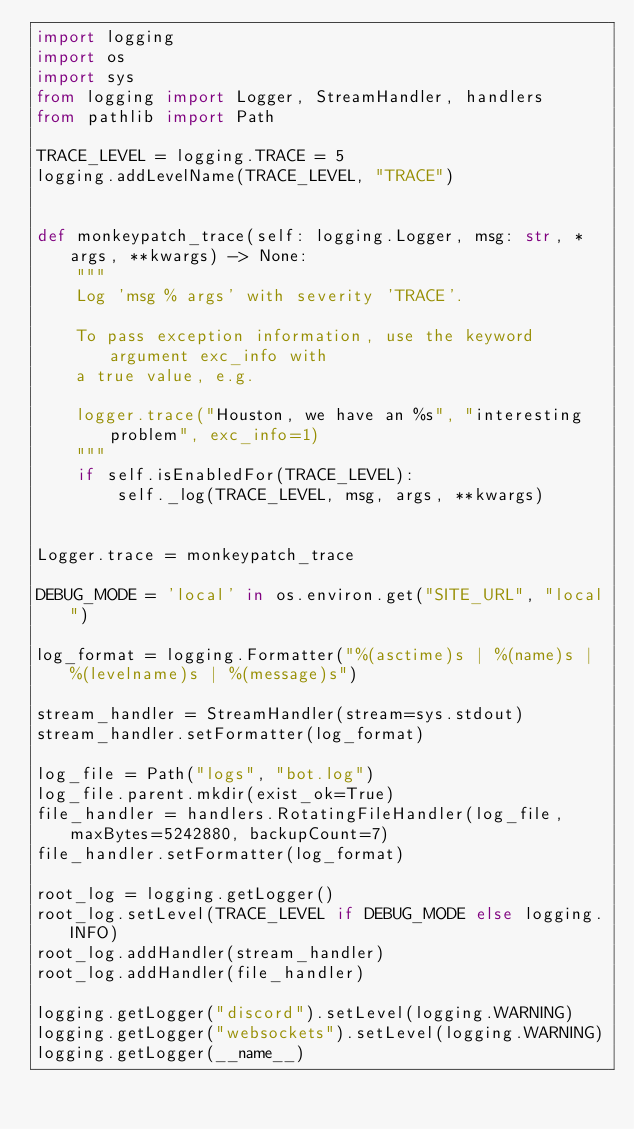<code> <loc_0><loc_0><loc_500><loc_500><_Python_>import logging
import os
import sys
from logging import Logger, StreamHandler, handlers
from pathlib import Path

TRACE_LEVEL = logging.TRACE = 5
logging.addLevelName(TRACE_LEVEL, "TRACE")


def monkeypatch_trace(self: logging.Logger, msg: str, *args, **kwargs) -> None:
    """
    Log 'msg % args' with severity 'TRACE'.

    To pass exception information, use the keyword argument exc_info with
    a true value, e.g.

    logger.trace("Houston, we have an %s", "interesting problem", exc_info=1)
    """
    if self.isEnabledFor(TRACE_LEVEL):
        self._log(TRACE_LEVEL, msg, args, **kwargs)


Logger.trace = monkeypatch_trace

DEBUG_MODE = 'local' in os.environ.get("SITE_URL", "local")

log_format = logging.Formatter("%(asctime)s | %(name)s | %(levelname)s | %(message)s")

stream_handler = StreamHandler(stream=sys.stdout)
stream_handler.setFormatter(log_format)

log_file = Path("logs", "bot.log")
log_file.parent.mkdir(exist_ok=True)
file_handler = handlers.RotatingFileHandler(log_file, maxBytes=5242880, backupCount=7)
file_handler.setFormatter(log_format)

root_log = logging.getLogger()
root_log.setLevel(TRACE_LEVEL if DEBUG_MODE else logging.INFO)
root_log.addHandler(stream_handler)
root_log.addHandler(file_handler)

logging.getLogger("discord").setLevel(logging.WARNING)
logging.getLogger("websockets").setLevel(logging.WARNING)
logging.getLogger(__name__)
</code> 